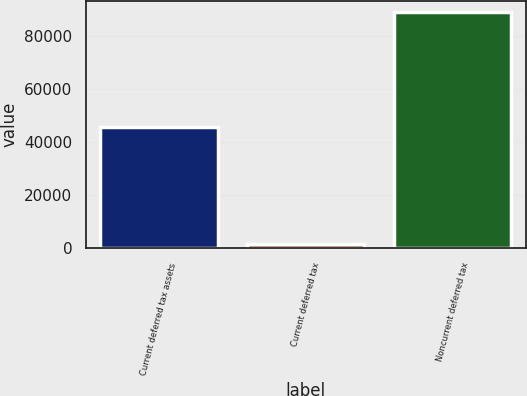Convert chart to OTSL. <chart><loc_0><loc_0><loc_500><loc_500><bar_chart><fcel>Current deferred tax assets<fcel>Current deferred tax<fcel>Noncurrent deferred tax<nl><fcel>45690<fcel>1561<fcel>88796<nl></chart> 